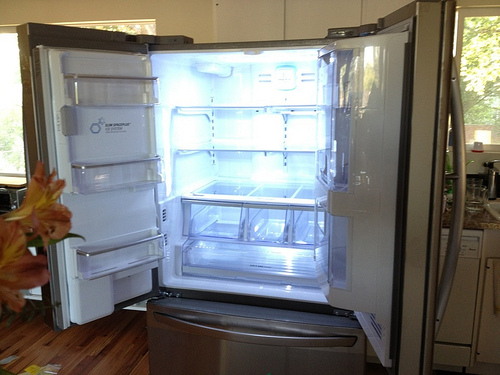Please provide the bounding box coordinate of the region this sentence describes: orange flowers in foreground of picture. The bounding box coordinates capturing the orange flowers prominently in the foreground should be adjusted to [0.01, 0.5, 0.25, 0.8] to more accurately reflect their position. 